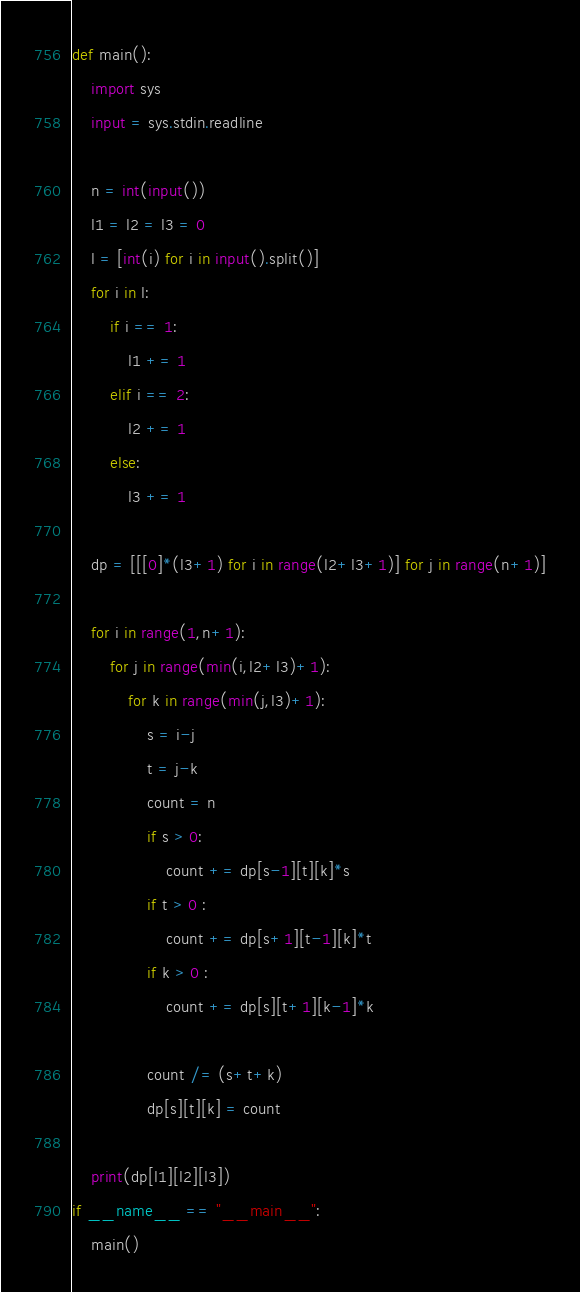<code> <loc_0><loc_0><loc_500><loc_500><_Python_>def main():
    import sys
    input = sys.stdin.readline

    n = int(input())
    l1 = l2 = l3 = 0
    l = [int(i) for i in input().split()]
    for i in l:
        if i == 1:
            l1 += 1
        elif i == 2:
            l2 += 1
        else:
            l3 += 1

    dp = [[[0]*(l3+1) for i in range(l2+l3+1)] for j in range(n+1)]

    for i in range(1,n+1):
        for j in range(min(i,l2+l3)+1):
            for k in range(min(j,l3)+1):
                s = i-j
                t = j-k
                count = n
                if s > 0:
                    count += dp[s-1][t][k]*s     
                if t > 0 :
                    count += dp[s+1][t-1][k]*t
                if k > 0 :
                    count += dp[s][t+1][k-1]*k

                count /= (s+t+k)
                dp[s][t][k] = count

    print(dp[l1][l2][l3])
if __name__ == "__main__":
    main()

</code> 